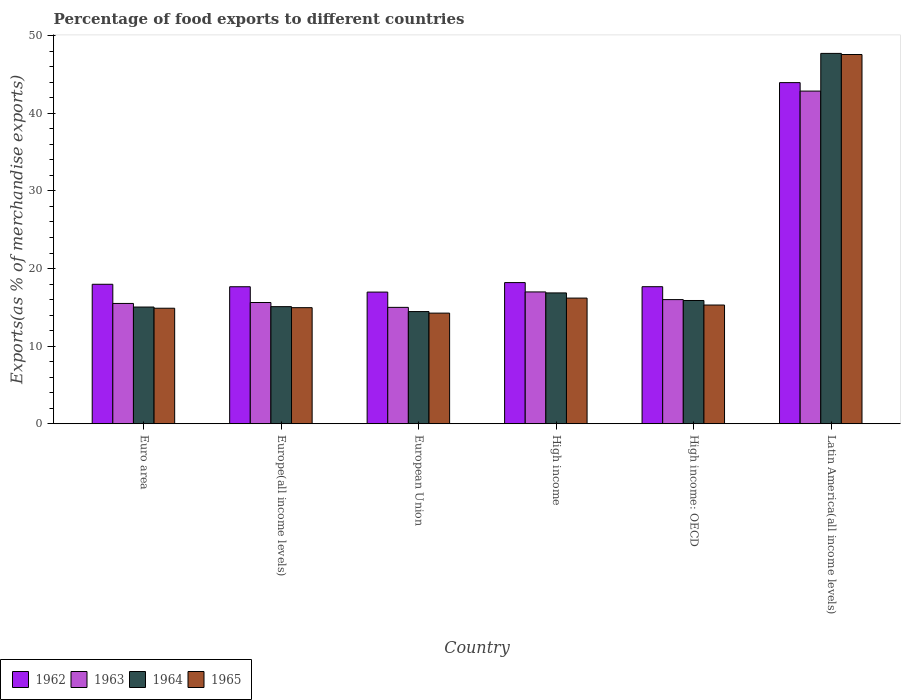How many different coloured bars are there?
Ensure brevity in your answer.  4. Are the number of bars per tick equal to the number of legend labels?
Provide a succinct answer. Yes. Are the number of bars on each tick of the X-axis equal?
Keep it short and to the point. Yes. What is the label of the 3rd group of bars from the left?
Make the answer very short. European Union. What is the percentage of exports to different countries in 1964 in High income: OECD?
Ensure brevity in your answer.  15.88. Across all countries, what is the maximum percentage of exports to different countries in 1963?
Ensure brevity in your answer.  42.86. Across all countries, what is the minimum percentage of exports to different countries in 1963?
Offer a terse response. 14.99. In which country was the percentage of exports to different countries in 1962 maximum?
Make the answer very short. Latin America(all income levels). In which country was the percentage of exports to different countries in 1963 minimum?
Offer a very short reply. European Union. What is the total percentage of exports to different countries in 1962 in the graph?
Give a very brief answer. 132.39. What is the difference between the percentage of exports to different countries in 1964 in European Union and that in High income: OECD?
Your response must be concise. -1.43. What is the difference between the percentage of exports to different countries in 1965 in European Union and the percentage of exports to different countries in 1963 in High income?
Your answer should be very brief. -2.73. What is the average percentage of exports to different countries in 1964 per country?
Give a very brief answer. 20.84. What is the difference between the percentage of exports to different countries of/in 1962 and percentage of exports to different countries of/in 1963 in Europe(all income levels)?
Make the answer very short. 2.03. What is the ratio of the percentage of exports to different countries in 1964 in Europe(all income levels) to that in High income: OECD?
Give a very brief answer. 0.95. Is the percentage of exports to different countries in 1963 in European Union less than that in High income: OECD?
Provide a short and direct response. Yes. What is the difference between the highest and the second highest percentage of exports to different countries in 1964?
Ensure brevity in your answer.  0.98. What is the difference between the highest and the lowest percentage of exports to different countries in 1964?
Give a very brief answer. 33.27. In how many countries, is the percentage of exports to different countries in 1964 greater than the average percentage of exports to different countries in 1964 taken over all countries?
Offer a terse response. 1. Is the sum of the percentage of exports to different countries in 1963 in Euro area and High income greater than the maximum percentage of exports to different countries in 1964 across all countries?
Give a very brief answer. No. Are all the bars in the graph horizontal?
Your response must be concise. No. What is the difference between two consecutive major ticks on the Y-axis?
Keep it short and to the point. 10. Does the graph contain any zero values?
Keep it short and to the point. No. Does the graph contain grids?
Ensure brevity in your answer.  No. Where does the legend appear in the graph?
Give a very brief answer. Bottom left. What is the title of the graph?
Keep it short and to the point. Percentage of food exports to different countries. What is the label or title of the Y-axis?
Your answer should be compact. Exports(as % of merchandise exports). What is the Exports(as % of merchandise exports) in 1962 in Euro area?
Your answer should be very brief. 17.97. What is the Exports(as % of merchandise exports) of 1963 in Euro area?
Your response must be concise. 15.5. What is the Exports(as % of merchandise exports) of 1964 in Euro area?
Give a very brief answer. 15.04. What is the Exports(as % of merchandise exports) of 1965 in Euro area?
Keep it short and to the point. 14.88. What is the Exports(as % of merchandise exports) of 1962 in Europe(all income levels)?
Give a very brief answer. 17.65. What is the Exports(as % of merchandise exports) in 1963 in Europe(all income levels)?
Offer a very short reply. 15.62. What is the Exports(as % of merchandise exports) of 1964 in Europe(all income levels)?
Your answer should be very brief. 15.09. What is the Exports(as % of merchandise exports) in 1965 in Europe(all income levels)?
Make the answer very short. 14.96. What is the Exports(as % of merchandise exports) in 1962 in European Union?
Your answer should be very brief. 16.96. What is the Exports(as % of merchandise exports) in 1963 in European Union?
Offer a very short reply. 14.99. What is the Exports(as % of merchandise exports) in 1964 in European Union?
Your answer should be compact. 14.45. What is the Exports(as % of merchandise exports) in 1965 in European Union?
Make the answer very short. 14.25. What is the Exports(as % of merchandise exports) in 1962 in High income?
Give a very brief answer. 18.19. What is the Exports(as % of merchandise exports) of 1963 in High income?
Ensure brevity in your answer.  16.98. What is the Exports(as % of merchandise exports) in 1964 in High income?
Offer a very short reply. 16.86. What is the Exports(as % of merchandise exports) of 1965 in High income?
Your answer should be compact. 16.19. What is the Exports(as % of merchandise exports) in 1962 in High income: OECD?
Ensure brevity in your answer.  17.66. What is the Exports(as % of merchandise exports) in 1963 in High income: OECD?
Provide a short and direct response. 16. What is the Exports(as % of merchandise exports) in 1964 in High income: OECD?
Give a very brief answer. 15.88. What is the Exports(as % of merchandise exports) in 1965 in High income: OECD?
Provide a succinct answer. 15.3. What is the Exports(as % of merchandise exports) of 1962 in Latin America(all income levels)?
Ensure brevity in your answer.  43.96. What is the Exports(as % of merchandise exports) in 1963 in Latin America(all income levels)?
Your response must be concise. 42.86. What is the Exports(as % of merchandise exports) in 1964 in Latin America(all income levels)?
Ensure brevity in your answer.  47.72. What is the Exports(as % of merchandise exports) in 1965 in Latin America(all income levels)?
Give a very brief answer. 47.58. Across all countries, what is the maximum Exports(as % of merchandise exports) in 1962?
Your response must be concise. 43.96. Across all countries, what is the maximum Exports(as % of merchandise exports) of 1963?
Keep it short and to the point. 42.86. Across all countries, what is the maximum Exports(as % of merchandise exports) of 1964?
Offer a very short reply. 47.72. Across all countries, what is the maximum Exports(as % of merchandise exports) in 1965?
Ensure brevity in your answer.  47.58. Across all countries, what is the minimum Exports(as % of merchandise exports) in 1962?
Give a very brief answer. 16.96. Across all countries, what is the minimum Exports(as % of merchandise exports) of 1963?
Your answer should be very brief. 14.99. Across all countries, what is the minimum Exports(as % of merchandise exports) of 1964?
Your answer should be very brief. 14.45. Across all countries, what is the minimum Exports(as % of merchandise exports) in 1965?
Offer a terse response. 14.25. What is the total Exports(as % of merchandise exports) in 1962 in the graph?
Offer a terse response. 132.39. What is the total Exports(as % of merchandise exports) in 1963 in the graph?
Offer a very short reply. 121.96. What is the total Exports(as % of merchandise exports) in 1964 in the graph?
Provide a short and direct response. 125.04. What is the total Exports(as % of merchandise exports) in 1965 in the graph?
Give a very brief answer. 123.16. What is the difference between the Exports(as % of merchandise exports) of 1962 in Euro area and that in Europe(all income levels)?
Provide a short and direct response. 0.32. What is the difference between the Exports(as % of merchandise exports) in 1963 in Euro area and that in Europe(all income levels)?
Ensure brevity in your answer.  -0.12. What is the difference between the Exports(as % of merchandise exports) of 1964 in Euro area and that in Europe(all income levels)?
Offer a terse response. -0.05. What is the difference between the Exports(as % of merchandise exports) in 1965 in Euro area and that in Europe(all income levels)?
Offer a very short reply. -0.07. What is the difference between the Exports(as % of merchandise exports) of 1962 in Euro area and that in European Union?
Ensure brevity in your answer.  1.01. What is the difference between the Exports(as % of merchandise exports) in 1963 in Euro area and that in European Union?
Make the answer very short. 0.51. What is the difference between the Exports(as % of merchandise exports) of 1964 in Euro area and that in European Union?
Keep it short and to the point. 0.58. What is the difference between the Exports(as % of merchandise exports) in 1965 in Euro area and that in European Union?
Your answer should be compact. 0.63. What is the difference between the Exports(as % of merchandise exports) in 1962 in Euro area and that in High income?
Make the answer very short. -0.22. What is the difference between the Exports(as % of merchandise exports) of 1963 in Euro area and that in High income?
Offer a terse response. -1.48. What is the difference between the Exports(as % of merchandise exports) of 1964 in Euro area and that in High income?
Your answer should be compact. -1.82. What is the difference between the Exports(as % of merchandise exports) of 1965 in Euro area and that in High income?
Provide a short and direct response. -1.31. What is the difference between the Exports(as % of merchandise exports) in 1962 in Euro area and that in High income: OECD?
Your answer should be compact. 0.31. What is the difference between the Exports(as % of merchandise exports) in 1963 in Euro area and that in High income: OECD?
Ensure brevity in your answer.  -0.49. What is the difference between the Exports(as % of merchandise exports) in 1964 in Euro area and that in High income: OECD?
Offer a terse response. -0.84. What is the difference between the Exports(as % of merchandise exports) in 1965 in Euro area and that in High income: OECD?
Provide a succinct answer. -0.41. What is the difference between the Exports(as % of merchandise exports) of 1962 in Euro area and that in Latin America(all income levels)?
Keep it short and to the point. -25.98. What is the difference between the Exports(as % of merchandise exports) in 1963 in Euro area and that in Latin America(all income levels)?
Provide a succinct answer. -27.36. What is the difference between the Exports(as % of merchandise exports) of 1964 in Euro area and that in Latin America(all income levels)?
Provide a succinct answer. -32.68. What is the difference between the Exports(as % of merchandise exports) in 1965 in Euro area and that in Latin America(all income levels)?
Make the answer very short. -32.69. What is the difference between the Exports(as % of merchandise exports) in 1962 in Europe(all income levels) and that in European Union?
Provide a short and direct response. 0.69. What is the difference between the Exports(as % of merchandise exports) in 1963 in Europe(all income levels) and that in European Union?
Your answer should be compact. 0.63. What is the difference between the Exports(as % of merchandise exports) of 1964 in Europe(all income levels) and that in European Union?
Provide a short and direct response. 0.63. What is the difference between the Exports(as % of merchandise exports) of 1965 in Europe(all income levels) and that in European Union?
Your answer should be compact. 0.7. What is the difference between the Exports(as % of merchandise exports) in 1962 in Europe(all income levels) and that in High income?
Provide a short and direct response. -0.54. What is the difference between the Exports(as % of merchandise exports) in 1963 in Europe(all income levels) and that in High income?
Give a very brief answer. -1.36. What is the difference between the Exports(as % of merchandise exports) in 1964 in Europe(all income levels) and that in High income?
Make the answer very short. -1.77. What is the difference between the Exports(as % of merchandise exports) in 1965 in Europe(all income levels) and that in High income?
Offer a terse response. -1.23. What is the difference between the Exports(as % of merchandise exports) of 1962 in Europe(all income levels) and that in High income: OECD?
Give a very brief answer. -0.01. What is the difference between the Exports(as % of merchandise exports) in 1963 in Europe(all income levels) and that in High income: OECD?
Ensure brevity in your answer.  -0.37. What is the difference between the Exports(as % of merchandise exports) of 1964 in Europe(all income levels) and that in High income: OECD?
Ensure brevity in your answer.  -0.79. What is the difference between the Exports(as % of merchandise exports) in 1965 in Europe(all income levels) and that in High income: OECD?
Your answer should be compact. -0.34. What is the difference between the Exports(as % of merchandise exports) of 1962 in Europe(all income levels) and that in Latin America(all income levels)?
Ensure brevity in your answer.  -26.3. What is the difference between the Exports(as % of merchandise exports) of 1963 in Europe(all income levels) and that in Latin America(all income levels)?
Keep it short and to the point. -27.24. What is the difference between the Exports(as % of merchandise exports) of 1964 in Europe(all income levels) and that in Latin America(all income levels)?
Ensure brevity in your answer.  -32.63. What is the difference between the Exports(as % of merchandise exports) in 1965 in Europe(all income levels) and that in Latin America(all income levels)?
Offer a very short reply. -32.62. What is the difference between the Exports(as % of merchandise exports) of 1962 in European Union and that in High income?
Provide a succinct answer. -1.22. What is the difference between the Exports(as % of merchandise exports) of 1963 in European Union and that in High income?
Your answer should be compact. -1.99. What is the difference between the Exports(as % of merchandise exports) in 1964 in European Union and that in High income?
Make the answer very short. -2.4. What is the difference between the Exports(as % of merchandise exports) in 1965 in European Union and that in High income?
Ensure brevity in your answer.  -1.94. What is the difference between the Exports(as % of merchandise exports) of 1962 in European Union and that in High income: OECD?
Your response must be concise. -0.7. What is the difference between the Exports(as % of merchandise exports) in 1963 in European Union and that in High income: OECD?
Offer a terse response. -1. What is the difference between the Exports(as % of merchandise exports) in 1964 in European Union and that in High income: OECD?
Ensure brevity in your answer.  -1.43. What is the difference between the Exports(as % of merchandise exports) in 1965 in European Union and that in High income: OECD?
Provide a succinct answer. -1.04. What is the difference between the Exports(as % of merchandise exports) in 1962 in European Union and that in Latin America(all income levels)?
Provide a short and direct response. -26.99. What is the difference between the Exports(as % of merchandise exports) in 1963 in European Union and that in Latin America(all income levels)?
Your answer should be very brief. -27.87. What is the difference between the Exports(as % of merchandise exports) of 1964 in European Union and that in Latin America(all income levels)?
Ensure brevity in your answer.  -33.27. What is the difference between the Exports(as % of merchandise exports) in 1965 in European Union and that in Latin America(all income levels)?
Provide a short and direct response. -33.32. What is the difference between the Exports(as % of merchandise exports) in 1962 in High income and that in High income: OECD?
Give a very brief answer. 0.53. What is the difference between the Exports(as % of merchandise exports) in 1964 in High income and that in High income: OECD?
Your answer should be compact. 0.98. What is the difference between the Exports(as % of merchandise exports) in 1965 in High income and that in High income: OECD?
Your answer should be compact. 0.89. What is the difference between the Exports(as % of merchandise exports) in 1962 in High income and that in Latin America(all income levels)?
Offer a terse response. -25.77. What is the difference between the Exports(as % of merchandise exports) in 1963 in High income and that in Latin America(all income levels)?
Provide a succinct answer. -25.88. What is the difference between the Exports(as % of merchandise exports) in 1964 in High income and that in Latin America(all income levels)?
Ensure brevity in your answer.  -30.86. What is the difference between the Exports(as % of merchandise exports) of 1965 in High income and that in Latin America(all income levels)?
Provide a succinct answer. -31.39. What is the difference between the Exports(as % of merchandise exports) in 1962 in High income: OECD and that in Latin America(all income levels)?
Your answer should be very brief. -26.3. What is the difference between the Exports(as % of merchandise exports) in 1963 in High income: OECD and that in Latin America(all income levels)?
Provide a succinct answer. -26.87. What is the difference between the Exports(as % of merchandise exports) in 1964 in High income: OECD and that in Latin America(all income levels)?
Your response must be concise. -31.84. What is the difference between the Exports(as % of merchandise exports) of 1965 in High income: OECD and that in Latin America(all income levels)?
Ensure brevity in your answer.  -32.28. What is the difference between the Exports(as % of merchandise exports) of 1962 in Euro area and the Exports(as % of merchandise exports) of 1963 in Europe(all income levels)?
Your answer should be very brief. 2.35. What is the difference between the Exports(as % of merchandise exports) in 1962 in Euro area and the Exports(as % of merchandise exports) in 1964 in Europe(all income levels)?
Ensure brevity in your answer.  2.88. What is the difference between the Exports(as % of merchandise exports) in 1962 in Euro area and the Exports(as % of merchandise exports) in 1965 in Europe(all income levels)?
Offer a very short reply. 3.02. What is the difference between the Exports(as % of merchandise exports) in 1963 in Euro area and the Exports(as % of merchandise exports) in 1964 in Europe(all income levels)?
Your response must be concise. 0.41. What is the difference between the Exports(as % of merchandise exports) in 1963 in Euro area and the Exports(as % of merchandise exports) in 1965 in Europe(all income levels)?
Provide a short and direct response. 0.55. What is the difference between the Exports(as % of merchandise exports) in 1964 in Euro area and the Exports(as % of merchandise exports) in 1965 in Europe(all income levels)?
Offer a very short reply. 0.08. What is the difference between the Exports(as % of merchandise exports) in 1962 in Euro area and the Exports(as % of merchandise exports) in 1963 in European Union?
Provide a short and direct response. 2.98. What is the difference between the Exports(as % of merchandise exports) in 1962 in Euro area and the Exports(as % of merchandise exports) in 1964 in European Union?
Give a very brief answer. 3.52. What is the difference between the Exports(as % of merchandise exports) in 1962 in Euro area and the Exports(as % of merchandise exports) in 1965 in European Union?
Provide a short and direct response. 3.72. What is the difference between the Exports(as % of merchandise exports) of 1963 in Euro area and the Exports(as % of merchandise exports) of 1964 in European Union?
Your answer should be compact. 1.05. What is the difference between the Exports(as % of merchandise exports) of 1963 in Euro area and the Exports(as % of merchandise exports) of 1965 in European Union?
Keep it short and to the point. 1.25. What is the difference between the Exports(as % of merchandise exports) of 1964 in Euro area and the Exports(as % of merchandise exports) of 1965 in European Union?
Provide a short and direct response. 0.78. What is the difference between the Exports(as % of merchandise exports) in 1962 in Euro area and the Exports(as % of merchandise exports) in 1963 in High income?
Make the answer very short. 0.99. What is the difference between the Exports(as % of merchandise exports) of 1962 in Euro area and the Exports(as % of merchandise exports) of 1964 in High income?
Your response must be concise. 1.11. What is the difference between the Exports(as % of merchandise exports) in 1962 in Euro area and the Exports(as % of merchandise exports) in 1965 in High income?
Your response must be concise. 1.78. What is the difference between the Exports(as % of merchandise exports) of 1963 in Euro area and the Exports(as % of merchandise exports) of 1964 in High income?
Provide a succinct answer. -1.36. What is the difference between the Exports(as % of merchandise exports) of 1963 in Euro area and the Exports(as % of merchandise exports) of 1965 in High income?
Give a very brief answer. -0.69. What is the difference between the Exports(as % of merchandise exports) in 1964 in Euro area and the Exports(as % of merchandise exports) in 1965 in High income?
Provide a short and direct response. -1.15. What is the difference between the Exports(as % of merchandise exports) in 1962 in Euro area and the Exports(as % of merchandise exports) in 1963 in High income: OECD?
Ensure brevity in your answer.  1.98. What is the difference between the Exports(as % of merchandise exports) of 1962 in Euro area and the Exports(as % of merchandise exports) of 1964 in High income: OECD?
Provide a short and direct response. 2.09. What is the difference between the Exports(as % of merchandise exports) of 1962 in Euro area and the Exports(as % of merchandise exports) of 1965 in High income: OECD?
Your answer should be compact. 2.67. What is the difference between the Exports(as % of merchandise exports) in 1963 in Euro area and the Exports(as % of merchandise exports) in 1964 in High income: OECD?
Offer a very short reply. -0.38. What is the difference between the Exports(as % of merchandise exports) of 1963 in Euro area and the Exports(as % of merchandise exports) of 1965 in High income: OECD?
Offer a very short reply. 0.2. What is the difference between the Exports(as % of merchandise exports) in 1964 in Euro area and the Exports(as % of merchandise exports) in 1965 in High income: OECD?
Keep it short and to the point. -0.26. What is the difference between the Exports(as % of merchandise exports) of 1962 in Euro area and the Exports(as % of merchandise exports) of 1963 in Latin America(all income levels)?
Keep it short and to the point. -24.89. What is the difference between the Exports(as % of merchandise exports) in 1962 in Euro area and the Exports(as % of merchandise exports) in 1964 in Latin America(all income levels)?
Your answer should be compact. -29.75. What is the difference between the Exports(as % of merchandise exports) of 1962 in Euro area and the Exports(as % of merchandise exports) of 1965 in Latin America(all income levels)?
Offer a very short reply. -29.61. What is the difference between the Exports(as % of merchandise exports) of 1963 in Euro area and the Exports(as % of merchandise exports) of 1964 in Latin America(all income levels)?
Ensure brevity in your answer.  -32.22. What is the difference between the Exports(as % of merchandise exports) in 1963 in Euro area and the Exports(as % of merchandise exports) in 1965 in Latin America(all income levels)?
Offer a terse response. -32.08. What is the difference between the Exports(as % of merchandise exports) of 1964 in Euro area and the Exports(as % of merchandise exports) of 1965 in Latin America(all income levels)?
Provide a short and direct response. -32.54. What is the difference between the Exports(as % of merchandise exports) in 1962 in Europe(all income levels) and the Exports(as % of merchandise exports) in 1963 in European Union?
Your response must be concise. 2.66. What is the difference between the Exports(as % of merchandise exports) in 1962 in Europe(all income levels) and the Exports(as % of merchandise exports) in 1964 in European Union?
Offer a terse response. 3.2. What is the difference between the Exports(as % of merchandise exports) of 1962 in Europe(all income levels) and the Exports(as % of merchandise exports) of 1965 in European Union?
Your response must be concise. 3.4. What is the difference between the Exports(as % of merchandise exports) of 1963 in Europe(all income levels) and the Exports(as % of merchandise exports) of 1964 in European Union?
Your answer should be compact. 1.17. What is the difference between the Exports(as % of merchandise exports) of 1963 in Europe(all income levels) and the Exports(as % of merchandise exports) of 1965 in European Union?
Your answer should be compact. 1.37. What is the difference between the Exports(as % of merchandise exports) in 1964 in Europe(all income levels) and the Exports(as % of merchandise exports) in 1965 in European Union?
Your answer should be compact. 0.83. What is the difference between the Exports(as % of merchandise exports) in 1962 in Europe(all income levels) and the Exports(as % of merchandise exports) in 1963 in High income?
Your response must be concise. 0.67. What is the difference between the Exports(as % of merchandise exports) of 1962 in Europe(all income levels) and the Exports(as % of merchandise exports) of 1964 in High income?
Give a very brief answer. 0.8. What is the difference between the Exports(as % of merchandise exports) of 1962 in Europe(all income levels) and the Exports(as % of merchandise exports) of 1965 in High income?
Your response must be concise. 1.46. What is the difference between the Exports(as % of merchandise exports) in 1963 in Europe(all income levels) and the Exports(as % of merchandise exports) in 1964 in High income?
Offer a terse response. -1.24. What is the difference between the Exports(as % of merchandise exports) of 1963 in Europe(all income levels) and the Exports(as % of merchandise exports) of 1965 in High income?
Provide a succinct answer. -0.57. What is the difference between the Exports(as % of merchandise exports) of 1964 in Europe(all income levels) and the Exports(as % of merchandise exports) of 1965 in High income?
Make the answer very short. -1.1. What is the difference between the Exports(as % of merchandise exports) in 1962 in Europe(all income levels) and the Exports(as % of merchandise exports) in 1963 in High income: OECD?
Keep it short and to the point. 1.66. What is the difference between the Exports(as % of merchandise exports) of 1962 in Europe(all income levels) and the Exports(as % of merchandise exports) of 1964 in High income: OECD?
Offer a very short reply. 1.77. What is the difference between the Exports(as % of merchandise exports) of 1962 in Europe(all income levels) and the Exports(as % of merchandise exports) of 1965 in High income: OECD?
Your answer should be very brief. 2.36. What is the difference between the Exports(as % of merchandise exports) of 1963 in Europe(all income levels) and the Exports(as % of merchandise exports) of 1964 in High income: OECD?
Provide a succinct answer. -0.26. What is the difference between the Exports(as % of merchandise exports) in 1963 in Europe(all income levels) and the Exports(as % of merchandise exports) in 1965 in High income: OECD?
Keep it short and to the point. 0.33. What is the difference between the Exports(as % of merchandise exports) in 1964 in Europe(all income levels) and the Exports(as % of merchandise exports) in 1965 in High income: OECD?
Offer a terse response. -0.21. What is the difference between the Exports(as % of merchandise exports) of 1962 in Europe(all income levels) and the Exports(as % of merchandise exports) of 1963 in Latin America(all income levels)?
Ensure brevity in your answer.  -25.21. What is the difference between the Exports(as % of merchandise exports) in 1962 in Europe(all income levels) and the Exports(as % of merchandise exports) in 1964 in Latin America(all income levels)?
Your answer should be compact. -30.07. What is the difference between the Exports(as % of merchandise exports) of 1962 in Europe(all income levels) and the Exports(as % of merchandise exports) of 1965 in Latin America(all income levels)?
Your answer should be very brief. -29.92. What is the difference between the Exports(as % of merchandise exports) of 1963 in Europe(all income levels) and the Exports(as % of merchandise exports) of 1964 in Latin America(all income levels)?
Ensure brevity in your answer.  -32.1. What is the difference between the Exports(as % of merchandise exports) in 1963 in Europe(all income levels) and the Exports(as % of merchandise exports) in 1965 in Latin America(all income levels)?
Your response must be concise. -31.96. What is the difference between the Exports(as % of merchandise exports) in 1964 in Europe(all income levels) and the Exports(as % of merchandise exports) in 1965 in Latin America(all income levels)?
Ensure brevity in your answer.  -32.49. What is the difference between the Exports(as % of merchandise exports) of 1962 in European Union and the Exports(as % of merchandise exports) of 1963 in High income?
Offer a very short reply. -0.02. What is the difference between the Exports(as % of merchandise exports) of 1962 in European Union and the Exports(as % of merchandise exports) of 1964 in High income?
Your answer should be compact. 0.11. What is the difference between the Exports(as % of merchandise exports) in 1962 in European Union and the Exports(as % of merchandise exports) in 1965 in High income?
Your answer should be very brief. 0.77. What is the difference between the Exports(as % of merchandise exports) of 1963 in European Union and the Exports(as % of merchandise exports) of 1964 in High income?
Your answer should be very brief. -1.86. What is the difference between the Exports(as % of merchandise exports) in 1963 in European Union and the Exports(as % of merchandise exports) in 1965 in High income?
Keep it short and to the point. -1.2. What is the difference between the Exports(as % of merchandise exports) in 1964 in European Union and the Exports(as % of merchandise exports) in 1965 in High income?
Keep it short and to the point. -1.74. What is the difference between the Exports(as % of merchandise exports) in 1962 in European Union and the Exports(as % of merchandise exports) in 1963 in High income: OECD?
Give a very brief answer. 0.97. What is the difference between the Exports(as % of merchandise exports) of 1962 in European Union and the Exports(as % of merchandise exports) of 1964 in High income: OECD?
Offer a terse response. 1.08. What is the difference between the Exports(as % of merchandise exports) in 1962 in European Union and the Exports(as % of merchandise exports) in 1965 in High income: OECD?
Offer a terse response. 1.67. What is the difference between the Exports(as % of merchandise exports) of 1963 in European Union and the Exports(as % of merchandise exports) of 1964 in High income: OECD?
Provide a short and direct response. -0.89. What is the difference between the Exports(as % of merchandise exports) of 1963 in European Union and the Exports(as % of merchandise exports) of 1965 in High income: OECD?
Provide a short and direct response. -0.3. What is the difference between the Exports(as % of merchandise exports) of 1964 in European Union and the Exports(as % of merchandise exports) of 1965 in High income: OECD?
Your response must be concise. -0.84. What is the difference between the Exports(as % of merchandise exports) of 1962 in European Union and the Exports(as % of merchandise exports) of 1963 in Latin America(all income levels)?
Offer a terse response. -25.9. What is the difference between the Exports(as % of merchandise exports) in 1962 in European Union and the Exports(as % of merchandise exports) in 1964 in Latin America(all income levels)?
Your answer should be compact. -30.76. What is the difference between the Exports(as % of merchandise exports) in 1962 in European Union and the Exports(as % of merchandise exports) in 1965 in Latin America(all income levels)?
Offer a terse response. -30.61. What is the difference between the Exports(as % of merchandise exports) of 1963 in European Union and the Exports(as % of merchandise exports) of 1964 in Latin America(all income levels)?
Offer a very short reply. -32.73. What is the difference between the Exports(as % of merchandise exports) in 1963 in European Union and the Exports(as % of merchandise exports) in 1965 in Latin America(all income levels)?
Ensure brevity in your answer.  -32.58. What is the difference between the Exports(as % of merchandise exports) in 1964 in European Union and the Exports(as % of merchandise exports) in 1965 in Latin America(all income levels)?
Your answer should be compact. -33.12. What is the difference between the Exports(as % of merchandise exports) of 1962 in High income and the Exports(as % of merchandise exports) of 1963 in High income: OECD?
Offer a very short reply. 2.19. What is the difference between the Exports(as % of merchandise exports) of 1962 in High income and the Exports(as % of merchandise exports) of 1964 in High income: OECD?
Your answer should be compact. 2.31. What is the difference between the Exports(as % of merchandise exports) in 1962 in High income and the Exports(as % of merchandise exports) in 1965 in High income: OECD?
Offer a terse response. 2.89. What is the difference between the Exports(as % of merchandise exports) in 1963 in High income and the Exports(as % of merchandise exports) in 1964 in High income: OECD?
Keep it short and to the point. 1.1. What is the difference between the Exports(as % of merchandise exports) of 1963 in High income and the Exports(as % of merchandise exports) of 1965 in High income: OECD?
Provide a short and direct response. 1.69. What is the difference between the Exports(as % of merchandise exports) in 1964 in High income and the Exports(as % of merchandise exports) in 1965 in High income: OECD?
Offer a terse response. 1.56. What is the difference between the Exports(as % of merchandise exports) of 1962 in High income and the Exports(as % of merchandise exports) of 1963 in Latin America(all income levels)?
Offer a terse response. -24.68. What is the difference between the Exports(as % of merchandise exports) in 1962 in High income and the Exports(as % of merchandise exports) in 1964 in Latin America(all income levels)?
Provide a short and direct response. -29.53. What is the difference between the Exports(as % of merchandise exports) of 1962 in High income and the Exports(as % of merchandise exports) of 1965 in Latin America(all income levels)?
Provide a succinct answer. -29.39. What is the difference between the Exports(as % of merchandise exports) in 1963 in High income and the Exports(as % of merchandise exports) in 1964 in Latin America(all income levels)?
Provide a succinct answer. -30.74. What is the difference between the Exports(as % of merchandise exports) of 1963 in High income and the Exports(as % of merchandise exports) of 1965 in Latin America(all income levels)?
Keep it short and to the point. -30.59. What is the difference between the Exports(as % of merchandise exports) in 1964 in High income and the Exports(as % of merchandise exports) in 1965 in Latin America(all income levels)?
Offer a terse response. -30.72. What is the difference between the Exports(as % of merchandise exports) of 1962 in High income: OECD and the Exports(as % of merchandise exports) of 1963 in Latin America(all income levels)?
Your response must be concise. -25.2. What is the difference between the Exports(as % of merchandise exports) in 1962 in High income: OECD and the Exports(as % of merchandise exports) in 1964 in Latin America(all income levels)?
Ensure brevity in your answer.  -30.06. What is the difference between the Exports(as % of merchandise exports) of 1962 in High income: OECD and the Exports(as % of merchandise exports) of 1965 in Latin America(all income levels)?
Ensure brevity in your answer.  -29.92. What is the difference between the Exports(as % of merchandise exports) in 1963 in High income: OECD and the Exports(as % of merchandise exports) in 1964 in Latin America(all income levels)?
Ensure brevity in your answer.  -31.73. What is the difference between the Exports(as % of merchandise exports) of 1963 in High income: OECD and the Exports(as % of merchandise exports) of 1965 in Latin America(all income levels)?
Offer a terse response. -31.58. What is the difference between the Exports(as % of merchandise exports) of 1964 in High income: OECD and the Exports(as % of merchandise exports) of 1965 in Latin America(all income levels)?
Offer a terse response. -31.7. What is the average Exports(as % of merchandise exports) in 1962 per country?
Keep it short and to the point. 22.07. What is the average Exports(as % of merchandise exports) in 1963 per country?
Ensure brevity in your answer.  20.33. What is the average Exports(as % of merchandise exports) in 1964 per country?
Keep it short and to the point. 20.84. What is the average Exports(as % of merchandise exports) of 1965 per country?
Offer a terse response. 20.53. What is the difference between the Exports(as % of merchandise exports) in 1962 and Exports(as % of merchandise exports) in 1963 in Euro area?
Ensure brevity in your answer.  2.47. What is the difference between the Exports(as % of merchandise exports) in 1962 and Exports(as % of merchandise exports) in 1964 in Euro area?
Your answer should be very brief. 2.93. What is the difference between the Exports(as % of merchandise exports) in 1962 and Exports(as % of merchandise exports) in 1965 in Euro area?
Make the answer very short. 3.09. What is the difference between the Exports(as % of merchandise exports) of 1963 and Exports(as % of merchandise exports) of 1964 in Euro area?
Make the answer very short. 0.46. What is the difference between the Exports(as % of merchandise exports) of 1963 and Exports(as % of merchandise exports) of 1965 in Euro area?
Make the answer very short. 0.62. What is the difference between the Exports(as % of merchandise exports) in 1964 and Exports(as % of merchandise exports) in 1965 in Euro area?
Your answer should be very brief. 0.15. What is the difference between the Exports(as % of merchandise exports) in 1962 and Exports(as % of merchandise exports) in 1963 in Europe(all income levels)?
Make the answer very short. 2.03. What is the difference between the Exports(as % of merchandise exports) in 1962 and Exports(as % of merchandise exports) in 1964 in Europe(all income levels)?
Make the answer very short. 2.57. What is the difference between the Exports(as % of merchandise exports) of 1962 and Exports(as % of merchandise exports) of 1965 in Europe(all income levels)?
Ensure brevity in your answer.  2.7. What is the difference between the Exports(as % of merchandise exports) of 1963 and Exports(as % of merchandise exports) of 1964 in Europe(all income levels)?
Ensure brevity in your answer.  0.53. What is the difference between the Exports(as % of merchandise exports) of 1963 and Exports(as % of merchandise exports) of 1965 in Europe(all income levels)?
Offer a terse response. 0.67. What is the difference between the Exports(as % of merchandise exports) of 1964 and Exports(as % of merchandise exports) of 1965 in Europe(all income levels)?
Give a very brief answer. 0.13. What is the difference between the Exports(as % of merchandise exports) of 1962 and Exports(as % of merchandise exports) of 1963 in European Union?
Ensure brevity in your answer.  1.97. What is the difference between the Exports(as % of merchandise exports) in 1962 and Exports(as % of merchandise exports) in 1964 in European Union?
Provide a short and direct response. 2.51. What is the difference between the Exports(as % of merchandise exports) of 1962 and Exports(as % of merchandise exports) of 1965 in European Union?
Your answer should be compact. 2.71. What is the difference between the Exports(as % of merchandise exports) in 1963 and Exports(as % of merchandise exports) in 1964 in European Union?
Provide a short and direct response. 0.54. What is the difference between the Exports(as % of merchandise exports) in 1963 and Exports(as % of merchandise exports) in 1965 in European Union?
Your response must be concise. 0.74. What is the difference between the Exports(as % of merchandise exports) of 1964 and Exports(as % of merchandise exports) of 1965 in European Union?
Ensure brevity in your answer.  0.2. What is the difference between the Exports(as % of merchandise exports) in 1962 and Exports(as % of merchandise exports) in 1963 in High income?
Offer a very short reply. 1.2. What is the difference between the Exports(as % of merchandise exports) in 1962 and Exports(as % of merchandise exports) in 1964 in High income?
Make the answer very short. 1.33. What is the difference between the Exports(as % of merchandise exports) of 1962 and Exports(as % of merchandise exports) of 1965 in High income?
Offer a very short reply. 2. What is the difference between the Exports(as % of merchandise exports) in 1963 and Exports(as % of merchandise exports) in 1964 in High income?
Offer a terse response. 0.13. What is the difference between the Exports(as % of merchandise exports) in 1963 and Exports(as % of merchandise exports) in 1965 in High income?
Provide a succinct answer. 0.79. What is the difference between the Exports(as % of merchandise exports) in 1964 and Exports(as % of merchandise exports) in 1965 in High income?
Your answer should be very brief. 0.67. What is the difference between the Exports(as % of merchandise exports) in 1962 and Exports(as % of merchandise exports) in 1963 in High income: OECD?
Give a very brief answer. 1.66. What is the difference between the Exports(as % of merchandise exports) of 1962 and Exports(as % of merchandise exports) of 1964 in High income: OECD?
Offer a terse response. 1.78. What is the difference between the Exports(as % of merchandise exports) of 1962 and Exports(as % of merchandise exports) of 1965 in High income: OECD?
Provide a succinct answer. 2.36. What is the difference between the Exports(as % of merchandise exports) in 1963 and Exports(as % of merchandise exports) in 1964 in High income: OECD?
Your answer should be compact. 0.12. What is the difference between the Exports(as % of merchandise exports) of 1963 and Exports(as % of merchandise exports) of 1965 in High income: OECD?
Your answer should be very brief. 0.7. What is the difference between the Exports(as % of merchandise exports) of 1964 and Exports(as % of merchandise exports) of 1965 in High income: OECD?
Make the answer very short. 0.58. What is the difference between the Exports(as % of merchandise exports) of 1962 and Exports(as % of merchandise exports) of 1963 in Latin America(all income levels)?
Your response must be concise. 1.09. What is the difference between the Exports(as % of merchandise exports) of 1962 and Exports(as % of merchandise exports) of 1964 in Latin America(all income levels)?
Your answer should be compact. -3.77. What is the difference between the Exports(as % of merchandise exports) of 1962 and Exports(as % of merchandise exports) of 1965 in Latin America(all income levels)?
Your answer should be compact. -3.62. What is the difference between the Exports(as % of merchandise exports) of 1963 and Exports(as % of merchandise exports) of 1964 in Latin America(all income levels)?
Make the answer very short. -4.86. What is the difference between the Exports(as % of merchandise exports) of 1963 and Exports(as % of merchandise exports) of 1965 in Latin America(all income levels)?
Keep it short and to the point. -4.71. What is the difference between the Exports(as % of merchandise exports) of 1964 and Exports(as % of merchandise exports) of 1965 in Latin America(all income levels)?
Ensure brevity in your answer.  0.14. What is the ratio of the Exports(as % of merchandise exports) in 1962 in Euro area to that in Europe(all income levels)?
Offer a very short reply. 1.02. What is the ratio of the Exports(as % of merchandise exports) in 1963 in Euro area to that in Europe(all income levels)?
Your answer should be compact. 0.99. What is the ratio of the Exports(as % of merchandise exports) of 1964 in Euro area to that in Europe(all income levels)?
Offer a terse response. 1. What is the ratio of the Exports(as % of merchandise exports) in 1965 in Euro area to that in Europe(all income levels)?
Your answer should be very brief. 1. What is the ratio of the Exports(as % of merchandise exports) in 1962 in Euro area to that in European Union?
Your answer should be compact. 1.06. What is the ratio of the Exports(as % of merchandise exports) in 1963 in Euro area to that in European Union?
Ensure brevity in your answer.  1.03. What is the ratio of the Exports(as % of merchandise exports) in 1964 in Euro area to that in European Union?
Ensure brevity in your answer.  1.04. What is the ratio of the Exports(as % of merchandise exports) of 1965 in Euro area to that in European Union?
Your answer should be very brief. 1.04. What is the ratio of the Exports(as % of merchandise exports) of 1962 in Euro area to that in High income?
Provide a succinct answer. 0.99. What is the ratio of the Exports(as % of merchandise exports) in 1963 in Euro area to that in High income?
Offer a very short reply. 0.91. What is the ratio of the Exports(as % of merchandise exports) of 1964 in Euro area to that in High income?
Make the answer very short. 0.89. What is the ratio of the Exports(as % of merchandise exports) of 1965 in Euro area to that in High income?
Your response must be concise. 0.92. What is the ratio of the Exports(as % of merchandise exports) of 1962 in Euro area to that in High income: OECD?
Provide a succinct answer. 1.02. What is the ratio of the Exports(as % of merchandise exports) of 1963 in Euro area to that in High income: OECD?
Give a very brief answer. 0.97. What is the ratio of the Exports(as % of merchandise exports) in 1964 in Euro area to that in High income: OECD?
Make the answer very short. 0.95. What is the ratio of the Exports(as % of merchandise exports) of 1965 in Euro area to that in High income: OECD?
Your response must be concise. 0.97. What is the ratio of the Exports(as % of merchandise exports) in 1962 in Euro area to that in Latin America(all income levels)?
Offer a very short reply. 0.41. What is the ratio of the Exports(as % of merchandise exports) of 1963 in Euro area to that in Latin America(all income levels)?
Provide a succinct answer. 0.36. What is the ratio of the Exports(as % of merchandise exports) in 1964 in Euro area to that in Latin America(all income levels)?
Your response must be concise. 0.32. What is the ratio of the Exports(as % of merchandise exports) in 1965 in Euro area to that in Latin America(all income levels)?
Your response must be concise. 0.31. What is the ratio of the Exports(as % of merchandise exports) in 1962 in Europe(all income levels) to that in European Union?
Your response must be concise. 1.04. What is the ratio of the Exports(as % of merchandise exports) in 1963 in Europe(all income levels) to that in European Union?
Provide a succinct answer. 1.04. What is the ratio of the Exports(as % of merchandise exports) in 1964 in Europe(all income levels) to that in European Union?
Make the answer very short. 1.04. What is the ratio of the Exports(as % of merchandise exports) of 1965 in Europe(all income levels) to that in European Union?
Give a very brief answer. 1.05. What is the ratio of the Exports(as % of merchandise exports) of 1962 in Europe(all income levels) to that in High income?
Give a very brief answer. 0.97. What is the ratio of the Exports(as % of merchandise exports) of 1963 in Europe(all income levels) to that in High income?
Your answer should be very brief. 0.92. What is the ratio of the Exports(as % of merchandise exports) of 1964 in Europe(all income levels) to that in High income?
Provide a succinct answer. 0.9. What is the ratio of the Exports(as % of merchandise exports) in 1965 in Europe(all income levels) to that in High income?
Provide a succinct answer. 0.92. What is the ratio of the Exports(as % of merchandise exports) in 1963 in Europe(all income levels) to that in High income: OECD?
Provide a short and direct response. 0.98. What is the ratio of the Exports(as % of merchandise exports) of 1964 in Europe(all income levels) to that in High income: OECD?
Offer a terse response. 0.95. What is the ratio of the Exports(as % of merchandise exports) of 1965 in Europe(all income levels) to that in High income: OECD?
Make the answer very short. 0.98. What is the ratio of the Exports(as % of merchandise exports) in 1962 in Europe(all income levels) to that in Latin America(all income levels)?
Ensure brevity in your answer.  0.4. What is the ratio of the Exports(as % of merchandise exports) of 1963 in Europe(all income levels) to that in Latin America(all income levels)?
Your response must be concise. 0.36. What is the ratio of the Exports(as % of merchandise exports) of 1964 in Europe(all income levels) to that in Latin America(all income levels)?
Offer a very short reply. 0.32. What is the ratio of the Exports(as % of merchandise exports) in 1965 in Europe(all income levels) to that in Latin America(all income levels)?
Ensure brevity in your answer.  0.31. What is the ratio of the Exports(as % of merchandise exports) of 1962 in European Union to that in High income?
Your answer should be very brief. 0.93. What is the ratio of the Exports(as % of merchandise exports) in 1963 in European Union to that in High income?
Give a very brief answer. 0.88. What is the ratio of the Exports(as % of merchandise exports) of 1964 in European Union to that in High income?
Keep it short and to the point. 0.86. What is the ratio of the Exports(as % of merchandise exports) in 1965 in European Union to that in High income?
Offer a terse response. 0.88. What is the ratio of the Exports(as % of merchandise exports) of 1962 in European Union to that in High income: OECD?
Keep it short and to the point. 0.96. What is the ratio of the Exports(as % of merchandise exports) in 1963 in European Union to that in High income: OECD?
Your response must be concise. 0.94. What is the ratio of the Exports(as % of merchandise exports) in 1964 in European Union to that in High income: OECD?
Your answer should be very brief. 0.91. What is the ratio of the Exports(as % of merchandise exports) in 1965 in European Union to that in High income: OECD?
Your answer should be compact. 0.93. What is the ratio of the Exports(as % of merchandise exports) of 1962 in European Union to that in Latin America(all income levels)?
Make the answer very short. 0.39. What is the ratio of the Exports(as % of merchandise exports) of 1963 in European Union to that in Latin America(all income levels)?
Keep it short and to the point. 0.35. What is the ratio of the Exports(as % of merchandise exports) in 1964 in European Union to that in Latin America(all income levels)?
Provide a short and direct response. 0.3. What is the ratio of the Exports(as % of merchandise exports) in 1965 in European Union to that in Latin America(all income levels)?
Your answer should be very brief. 0.3. What is the ratio of the Exports(as % of merchandise exports) of 1962 in High income to that in High income: OECD?
Your response must be concise. 1.03. What is the ratio of the Exports(as % of merchandise exports) in 1963 in High income to that in High income: OECD?
Offer a very short reply. 1.06. What is the ratio of the Exports(as % of merchandise exports) of 1964 in High income to that in High income: OECD?
Your response must be concise. 1.06. What is the ratio of the Exports(as % of merchandise exports) in 1965 in High income to that in High income: OECD?
Keep it short and to the point. 1.06. What is the ratio of the Exports(as % of merchandise exports) of 1962 in High income to that in Latin America(all income levels)?
Provide a succinct answer. 0.41. What is the ratio of the Exports(as % of merchandise exports) of 1963 in High income to that in Latin America(all income levels)?
Offer a very short reply. 0.4. What is the ratio of the Exports(as % of merchandise exports) in 1964 in High income to that in Latin America(all income levels)?
Offer a very short reply. 0.35. What is the ratio of the Exports(as % of merchandise exports) in 1965 in High income to that in Latin America(all income levels)?
Offer a terse response. 0.34. What is the ratio of the Exports(as % of merchandise exports) in 1962 in High income: OECD to that in Latin America(all income levels)?
Offer a very short reply. 0.4. What is the ratio of the Exports(as % of merchandise exports) of 1963 in High income: OECD to that in Latin America(all income levels)?
Give a very brief answer. 0.37. What is the ratio of the Exports(as % of merchandise exports) in 1964 in High income: OECD to that in Latin America(all income levels)?
Make the answer very short. 0.33. What is the ratio of the Exports(as % of merchandise exports) in 1965 in High income: OECD to that in Latin America(all income levels)?
Your answer should be very brief. 0.32. What is the difference between the highest and the second highest Exports(as % of merchandise exports) in 1962?
Offer a terse response. 25.77. What is the difference between the highest and the second highest Exports(as % of merchandise exports) in 1963?
Ensure brevity in your answer.  25.88. What is the difference between the highest and the second highest Exports(as % of merchandise exports) in 1964?
Make the answer very short. 30.86. What is the difference between the highest and the second highest Exports(as % of merchandise exports) of 1965?
Provide a short and direct response. 31.39. What is the difference between the highest and the lowest Exports(as % of merchandise exports) of 1962?
Your answer should be compact. 26.99. What is the difference between the highest and the lowest Exports(as % of merchandise exports) in 1963?
Your answer should be very brief. 27.87. What is the difference between the highest and the lowest Exports(as % of merchandise exports) of 1964?
Ensure brevity in your answer.  33.27. What is the difference between the highest and the lowest Exports(as % of merchandise exports) in 1965?
Keep it short and to the point. 33.32. 